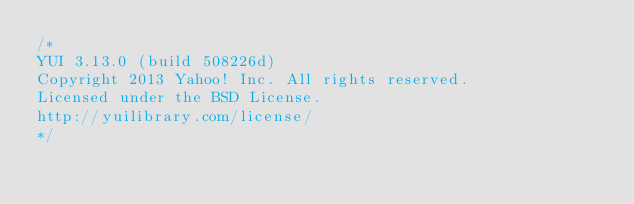<code> <loc_0><loc_0><loc_500><loc_500><_JavaScript_>/*
YUI 3.13.0 (build 508226d)
Copyright 2013 Yahoo! Inc. All rights reserved.
Licensed under the BSD License.
http://yuilibrary.com/license/
*/
</code> 